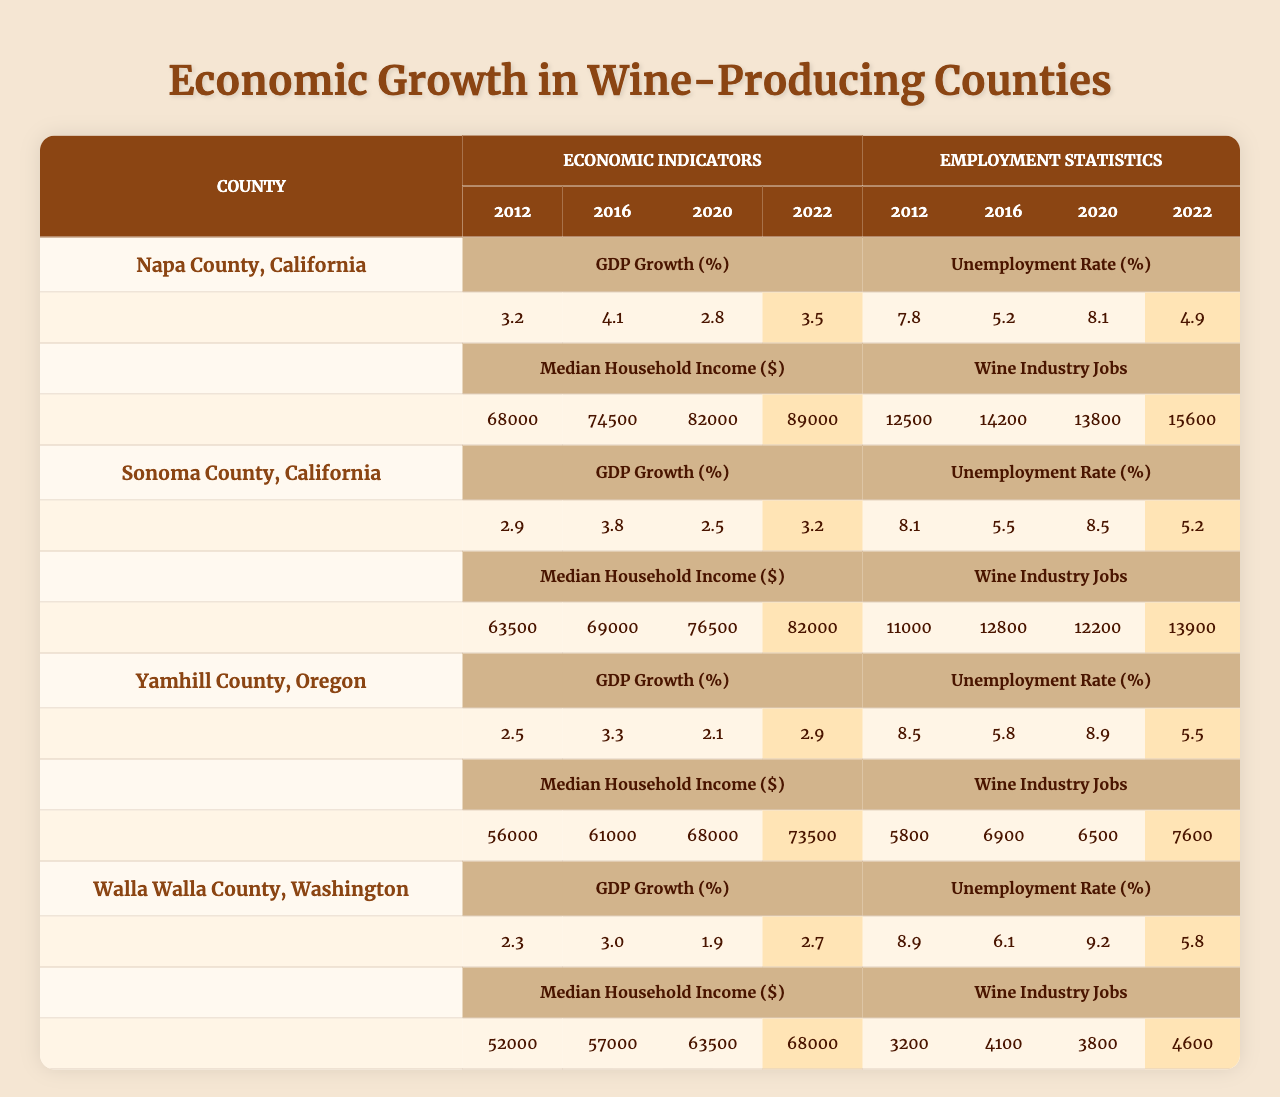What was the GDP growth percentage of Napa County in 2022? According to the table, the GDP growth percentage for Napa County in 2022 is listed as 3.5%.
Answer: 3.5% What is the median household income in Sonoma County in 2020? The median household income for Sonoma County in 2020 can be found in the table, which shows it as $76,500.
Answer: $76,500 Which county had the highest number of wine industry jobs in 2022? The table shows that Napa County had the highest number of wine industry jobs in 2022 at 15,600.
Answer: Napa County What is the difference in unemployment rates between Yamhill County in 2012 and 2022? Looking at the table, the unemployment rate in Yamhill County was 8.5% in 2012 and 5.5% in 2022. The difference is 8.5% - 5.5% = 3%.
Answer: 3% Was there an increase in median household income in Walla Walla County from 2012 to 2022? The table shows the median household income for Walla Walla County was $52,000 in 2012 and $68,000 in 2022. Therefore, there was an increase of $68,000 - $52,000 = $16,000.
Answer: Yes What is the average unemployment rate for Sonoma County over the decade? To find the average, sum the unemployment rates for the years: (8.1 + 5.5 + 8.5 + 5.2) = 27.3% and divide by 4, giving 27.3% / 4 = 6.825%.
Answer: 6.83% How much did the median household income increase from 2012 to 2022 in Napa County? Napa County had a median household income of $68,000 in 2012 and $89,000 in 2022. The increase is $89,000 - $68,000 = $21,000.
Answer: $21,000 Does Yamhill County have a lower unemployment rate in 2022 compared to 2020? Checking the table, the unemployment rates for Yamhill County are 8.9% in 2020 and 5.5% in 2022. Therefore, the unemployment rate is lower in 2022.
Answer: Yes How did the GDP growth rate for Walla Walla County change from 2016 to 2020? The GDP growth rates for Walla Walla County were 3.0% in 2016 and 1.9% in 2020. The growth rate decreased by 3.0% - 1.9% = 1.1%.
Answer: Decreased by 1.1% What percentage of wine industry jobs in Napa County were recorded in 2012? The table indicates that there were 12,500 wine industry jobs in Napa County in 2012.
Answer: 12,500 Which county had the lowest GDP growth percentage in 2020? Looking at 2020 GDP growth percentages, Yamhill County had the lowest at 2.1%.
Answer: Yamhill County 